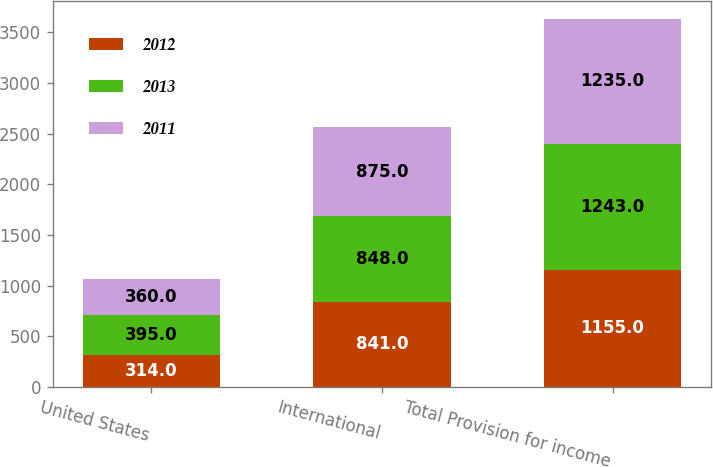Convert chart. <chart><loc_0><loc_0><loc_500><loc_500><stacked_bar_chart><ecel><fcel>United States<fcel>International<fcel>Total Provision for income<nl><fcel>2012<fcel>314<fcel>841<fcel>1155<nl><fcel>2013<fcel>395<fcel>848<fcel>1243<nl><fcel>2011<fcel>360<fcel>875<fcel>1235<nl></chart> 